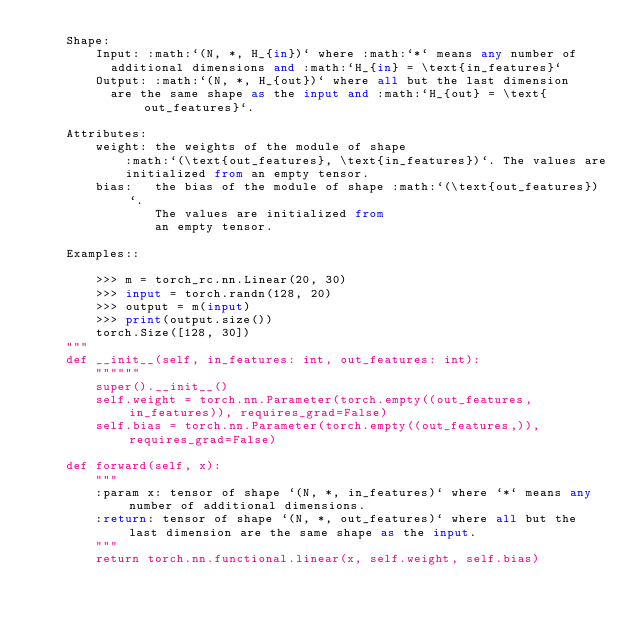<code> <loc_0><loc_0><loc_500><loc_500><_Python_>    Shape:
        Input: :math:`(N, *, H_{in})` where :math:`*` means any number of
          additional dimensions and :math:`H_{in} = \text{in_features}`
        Output: :math:`(N, *, H_{out})` where all but the last dimension
          are the same shape as the input and :math:`H_{out} = \text{out_features}`.

    Attributes:
        weight: the weights of the module of shape
            :math:`(\text{out_features}, \text{in_features})`. The values are
            initialized from an empty tensor.
        bias:   the bias of the module of shape :math:`(\text{out_features})`.
                The values are initialized from
                an empty tensor.

    Examples::

        >>> m = torch_rc.nn.Linear(20, 30)
        >>> input = torch.randn(128, 20)
        >>> output = m(input)
        >>> print(output.size())
        torch.Size([128, 30])
    """
    def __init__(self, in_features: int, out_features: int):
        """"""
        super().__init__()
        self.weight = torch.nn.Parameter(torch.empty((out_features, in_features)), requires_grad=False)
        self.bias = torch.nn.Parameter(torch.empty((out_features,)), requires_grad=False)

    def forward(self, x):
        """
        :param x: tensor of shape `(N, *, in_features)` where `*` means any number of additional dimensions.
        :return: tensor of shape `(N, *, out_features)` where all but the last dimension are the same shape as the input.
        """
        return torch.nn.functional.linear(x, self.weight, self.bias)
</code> 